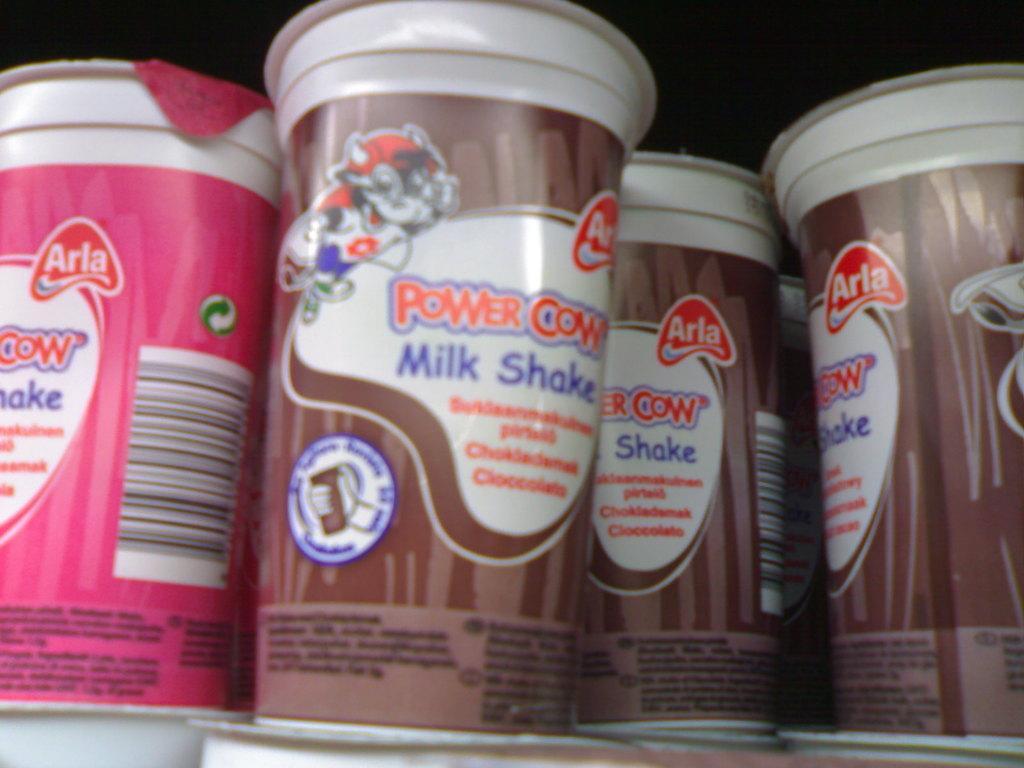Can you describe this image briefly? In this image we can see cups. In the background the image is dark. 